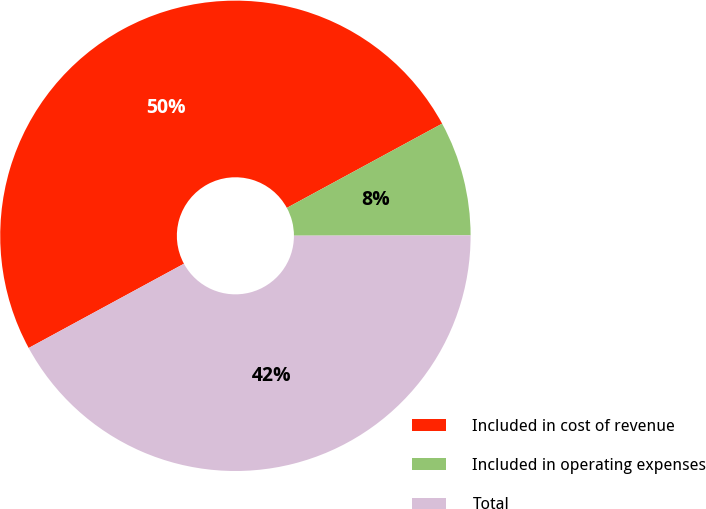<chart> <loc_0><loc_0><loc_500><loc_500><pie_chart><fcel>Included in cost of revenue<fcel>Included in operating expenses<fcel>Total<nl><fcel>50.0%<fcel>7.88%<fcel>42.12%<nl></chart> 